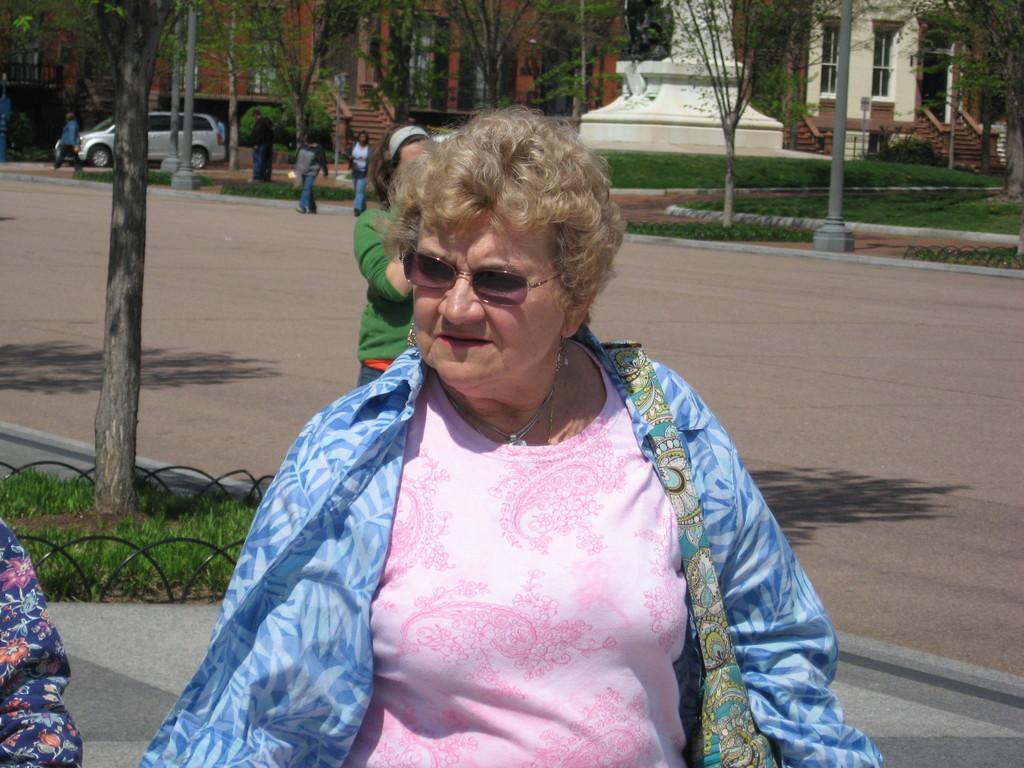Can you describe this image briefly? In this image in the middle, there is a woman, she wears a t shirt, shirt, bag, her hair is short. In the background there are some people, cars, buildings, poles, grass, plants, trees and road. 